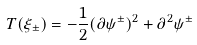<formula> <loc_0><loc_0><loc_500><loc_500>T ( \xi _ { \pm } ) = - \frac { 1 } { 2 } ( \partial \psi ^ { \pm } ) ^ { 2 } + \partial ^ { 2 } \psi ^ { \pm }</formula> 